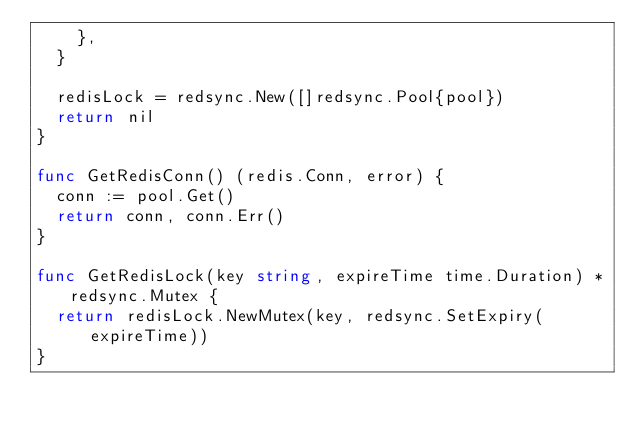<code> <loc_0><loc_0><loc_500><loc_500><_Go_>		},
	}

	redisLock = redsync.New([]redsync.Pool{pool})
	return nil
}

func GetRedisConn() (redis.Conn, error) {
	conn := pool.Get()
	return conn, conn.Err()
}

func GetRedisLock(key string, expireTime time.Duration) *redsync.Mutex {
	return redisLock.NewMutex(key, redsync.SetExpiry(expireTime))
}
</code> 